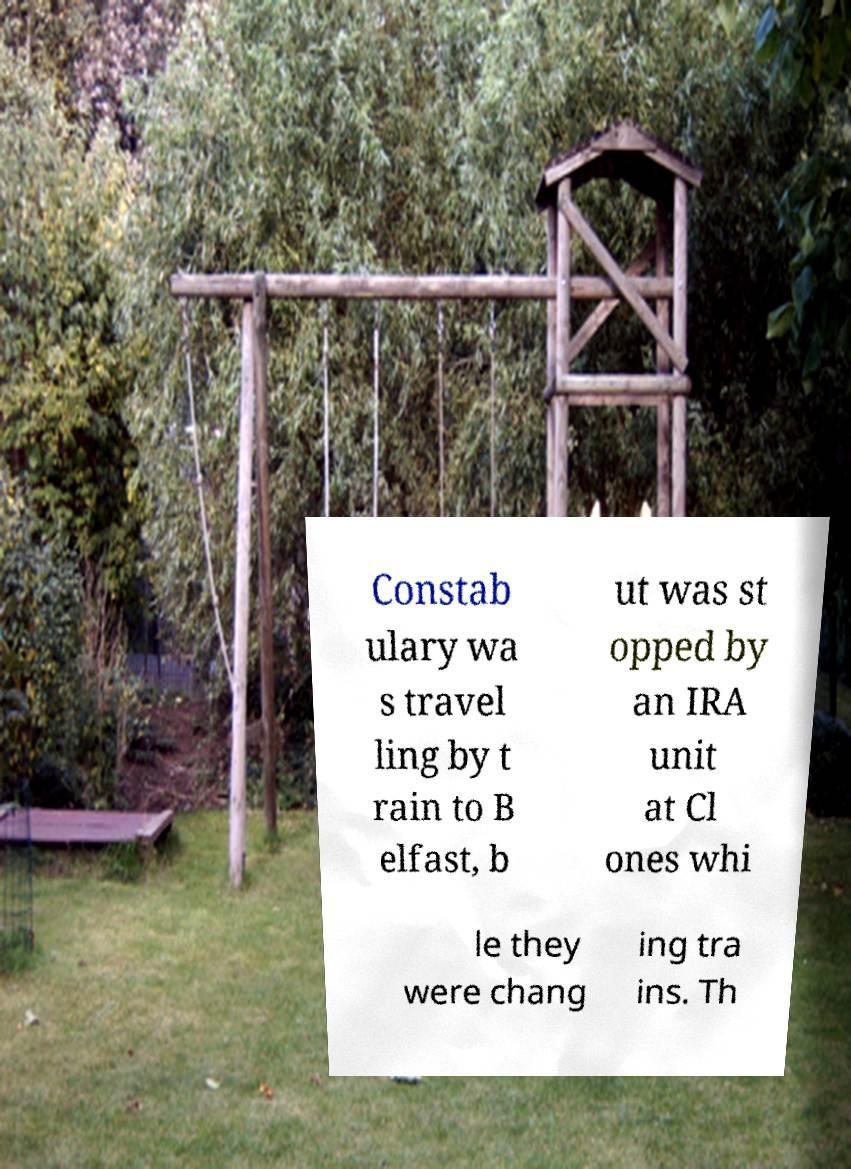Can you accurately transcribe the text from the provided image for me? Constab ulary wa s travel ling by t rain to B elfast, b ut was st opped by an IRA unit at Cl ones whi le they were chang ing tra ins. Th 